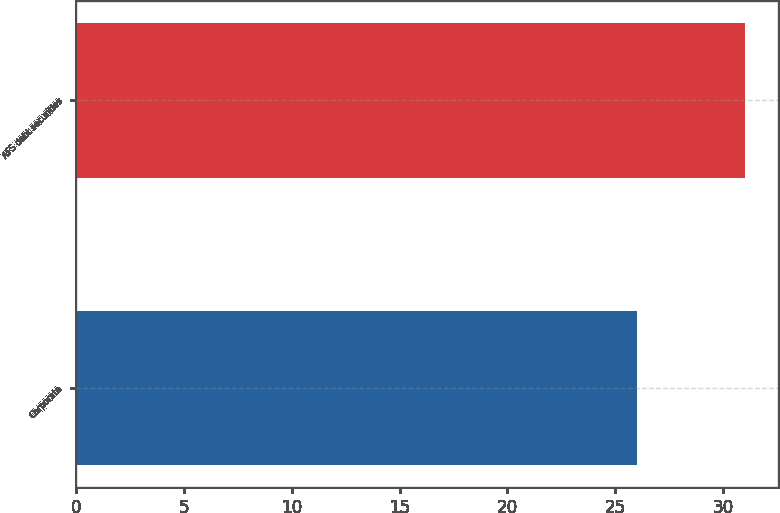Convert chart. <chart><loc_0><loc_0><loc_500><loc_500><bar_chart><fcel>Corporate<fcel>AFS debt securities<nl><fcel>26<fcel>31<nl></chart> 